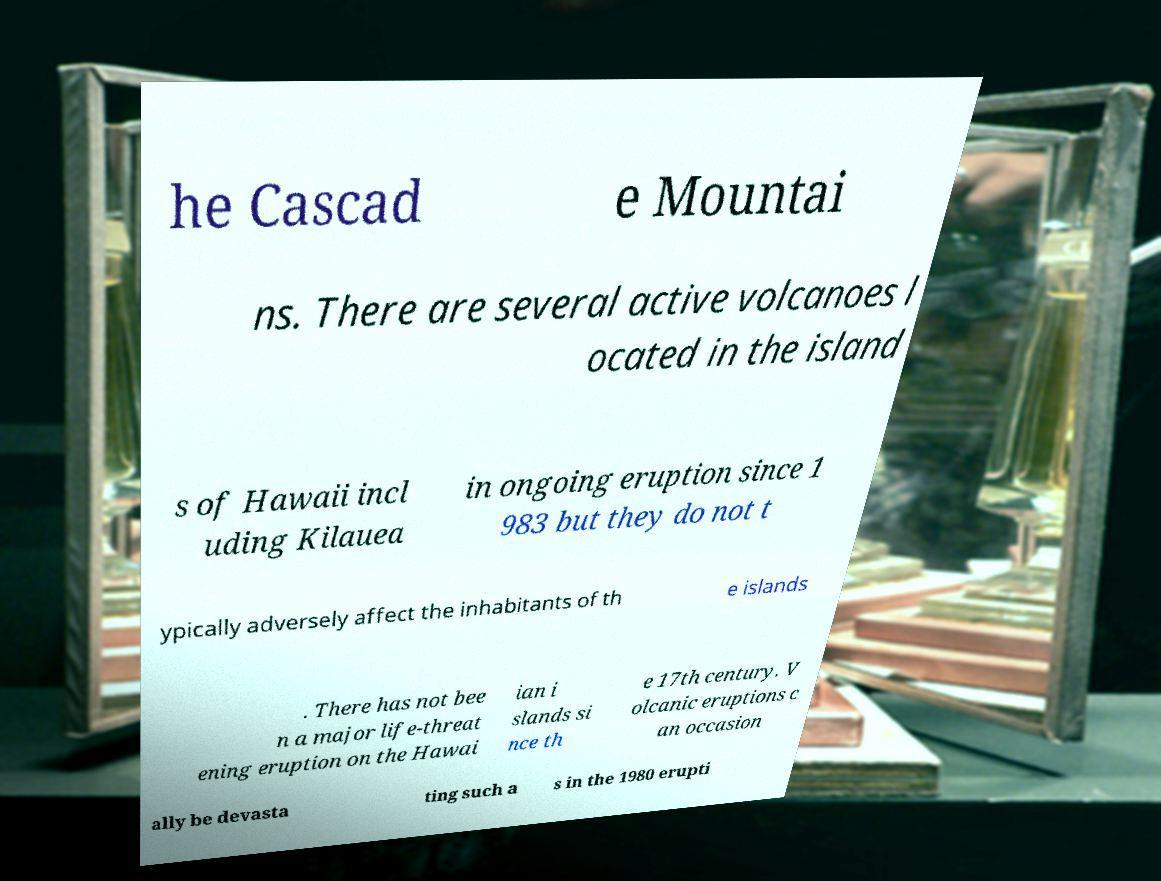Please read and relay the text visible in this image. What does it say? he Cascad e Mountai ns. There are several active volcanoes l ocated in the island s of Hawaii incl uding Kilauea in ongoing eruption since 1 983 but they do not t ypically adversely affect the inhabitants of th e islands . There has not bee n a major life-threat ening eruption on the Hawai ian i slands si nce th e 17th century. V olcanic eruptions c an occasion ally be devasta ting such a s in the 1980 erupti 